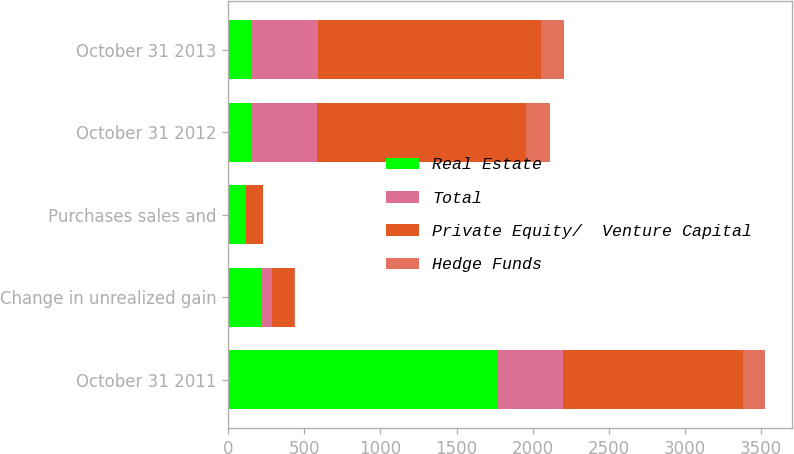Convert chart to OTSL. <chart><loc_0><loc_0><loc_500><loc_500><stacked_bar_chart><ecel><fcel>October 31 2011<fcel>Change in unrealized gain<fcel>Purchases sales and<fcel>October 31 2012<fcel>October 31 2013<nl><fcel>Real Estate<fcel>1765<fcel>220<fcel>112<fcel>146<fcel>146<nl><fcel>Total<fcel>437<fcel>68<fcel>3<fcel>436<fcel>443<nl><fcel>Private Equity/  Venture Capital<fcel>1178<fcel>142<fcel>112<fcel>1373<fcel>1464<nl><fcel>Hedge Funds<fcel>150<fcel>10<fcel>3<fcel>160<fcel>155<nl></chart> 